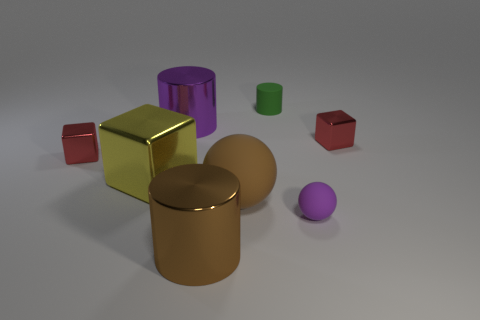How many yellow objects are either big things or cylinders?
Your answer should be very brief. 1. Is there a small matte thing of the same color as the large rubber object?
Give a very brief answer. No. The purple object that is the same material as the green object is what size?
Keep it short and to the point. Small. How many cylinders are either purple rubber things or purple metallic objects?
Your response must be concise. 1. Is the number of brown shiny objects greater than the number of yellow rubber cubes?
Give a very brief answer. Yes. How many matte objects are the same size as the matte cylinder?
Your response must be concise. 1. There is a large object that is the same color as the small matte sphere; what shape is it?
Offer a terse response. Cylinder. What number of objects are large brown shiny things in front of the big matte object or matte things?
Provide a succinct answer. 4. Are there fewer tiny cyan cylinders than purple objects?
Your answer should be very brief. Yes. What is the shape of the brown object that is the same material as the tiny cylinder?
Offer a terse response. Sphere. 